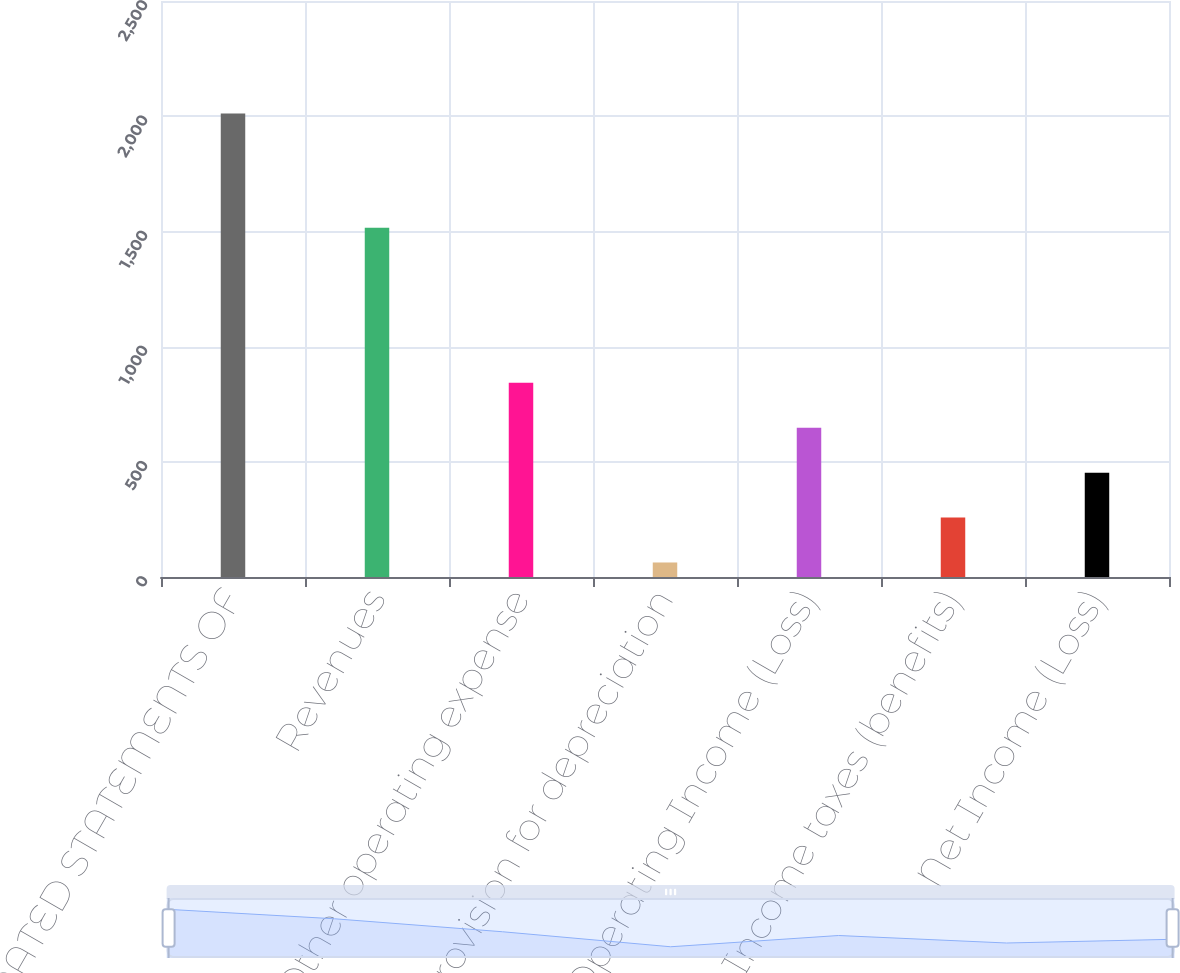Convert chart to OTSL. <chart><loc_0><loc_0><loc_500><loc_500><bar_chart><fcel>CONSOLIDATED STATEMENTS OF<fcel>Revenues<fcel>Other operating expense<fcel>Provision for depreciation<fcel>Operating Income (Loss)<fcel>Income taxes (benefits)<fcel>Net Income (Loss)<nl><fcel>2012<fcel>1516<fcel>842.6<fcel>63<fcel>647.7<fcel>257.9<fcel>452.8<nl></chart> 